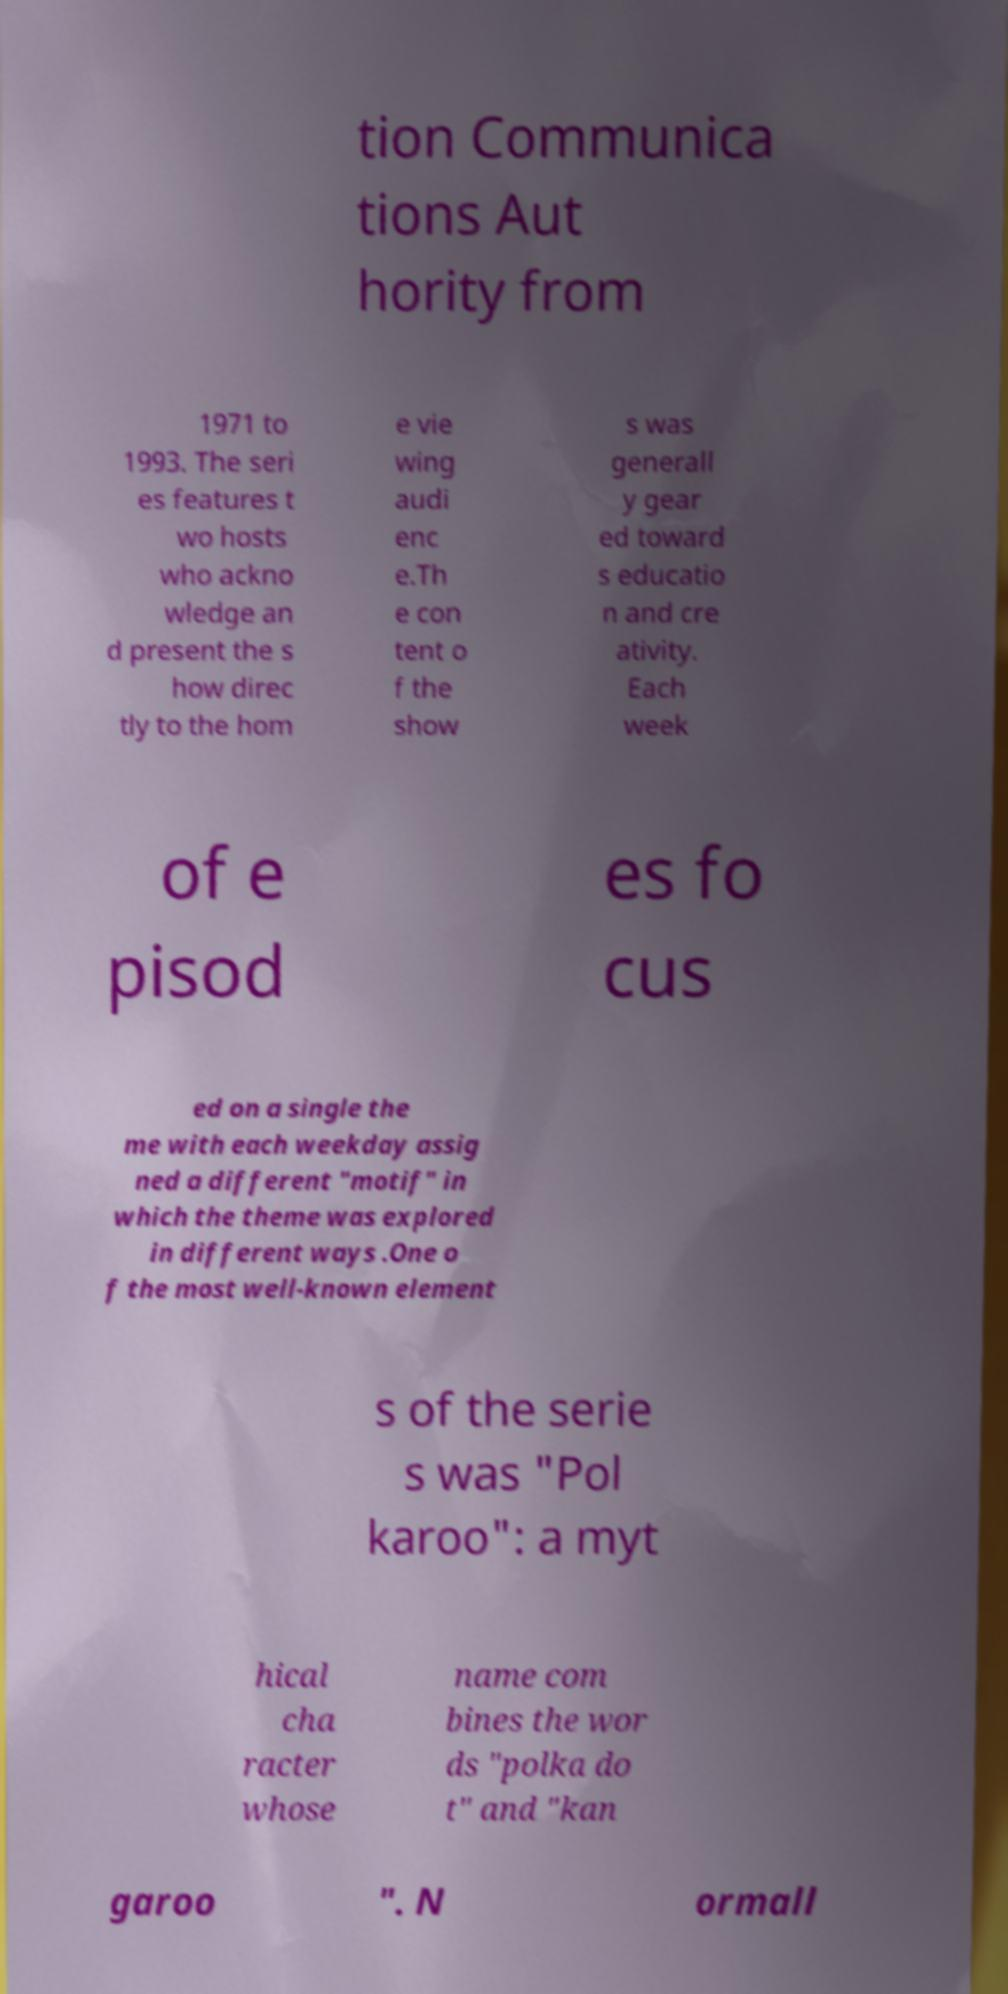Can you read and provide the text displayed in the image?This photo seems to have some interesting text. Can you extract and type it out for me? tion Communica tions Aut hority from 1971 to 1993. The seri es features t wo hosts who ackno wledge an d present the s how direc tly to the hom e vie wing audi enc e.Th e con tent o f the show s was generall y gear ed toward s educatio n and cre ativity. Each week of e pisod es fo cus ed on a single the me with each weekday assig ned a different "motif" in which the theme was explored in different ways .One o f the most well-known element s of the serie s was "Pol karoo": a myt hical cha racter whose name com bines the wor ds "polka do t" and "kan garoo ". N ormall 